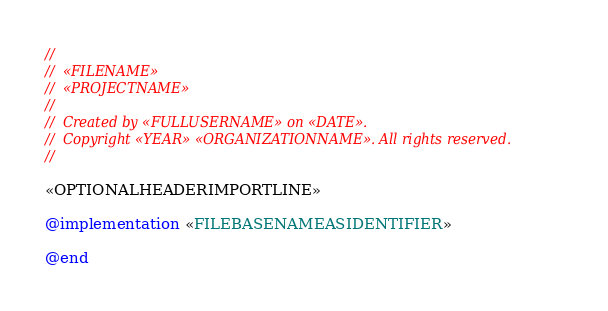<code> <loc_0><loc_0><loc_500><loc_500><_ObjectiveC_>//
//  «FILENAME»
//  «PROJECTNAME»
//
//  Created by «FULLUSERNAME» on «DATE».
//  Copyright «YEAR» «ORGANIZATIONNAME». All rights reserved.
//

«OPTIONALHEADERIMPORTLINE»

@implementation «FILEBASENAMEASIDENTIFIER»

@end
</code> 